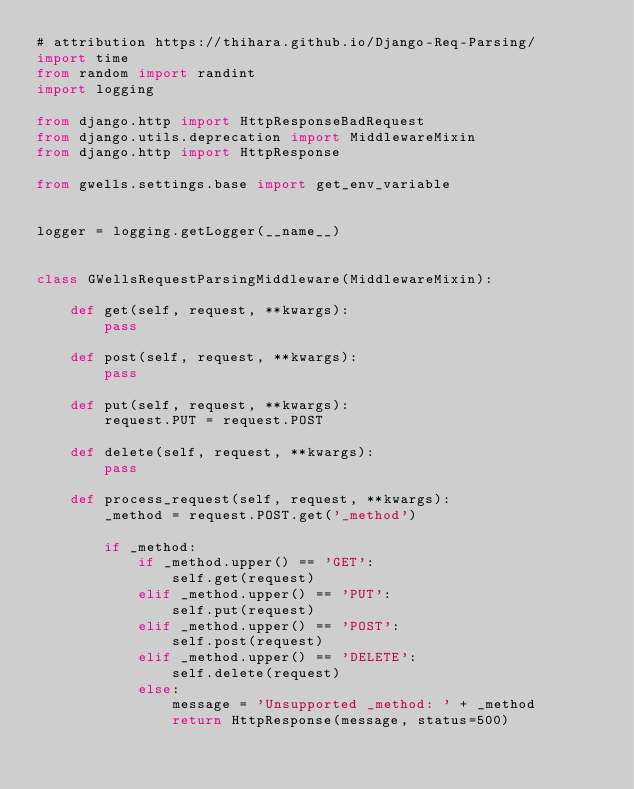<code> <loc_0><loc_0><loc_500><loc_500><_Python_># attribution https://thihara.github.io/Django-Req-Parsing/
import time
from random import randint
import logging

from django.http import HttpResponseBadRequest
from django.utils.deprecation import MiddlewareMixin
from django.http import HttpResponse

from gwells.settings.base import get_env_variable


logger = logging.getLogger(__name__)


class GWellsRequestParsingMiddleware(MiddlewareMixin):

    def get(self, request, **kwargs):
        pass

    def post(self, request, **kwargs):
        pass

    def put(self, request, **kwargs):
        request.PUT = request.POST

    def delete(self, request, **kwargs):
        pass

    def process_request(self, request, **kwargs):
        _method = request.POST.get('_method')

        if _method:
            if _method.upper() == 'GET':
                self.get(request)
            elif _method.upper() == 'PUT':
                self.put(request)
            elif _method.upper() == 'POST':
                self.post(request)
            elif _method.upper() == 'DELETE':
                self.delete(request)
            else:
                message = 'Unsupported _method: ' + _method
                return HttpResponse(message, status=500)
</code> 